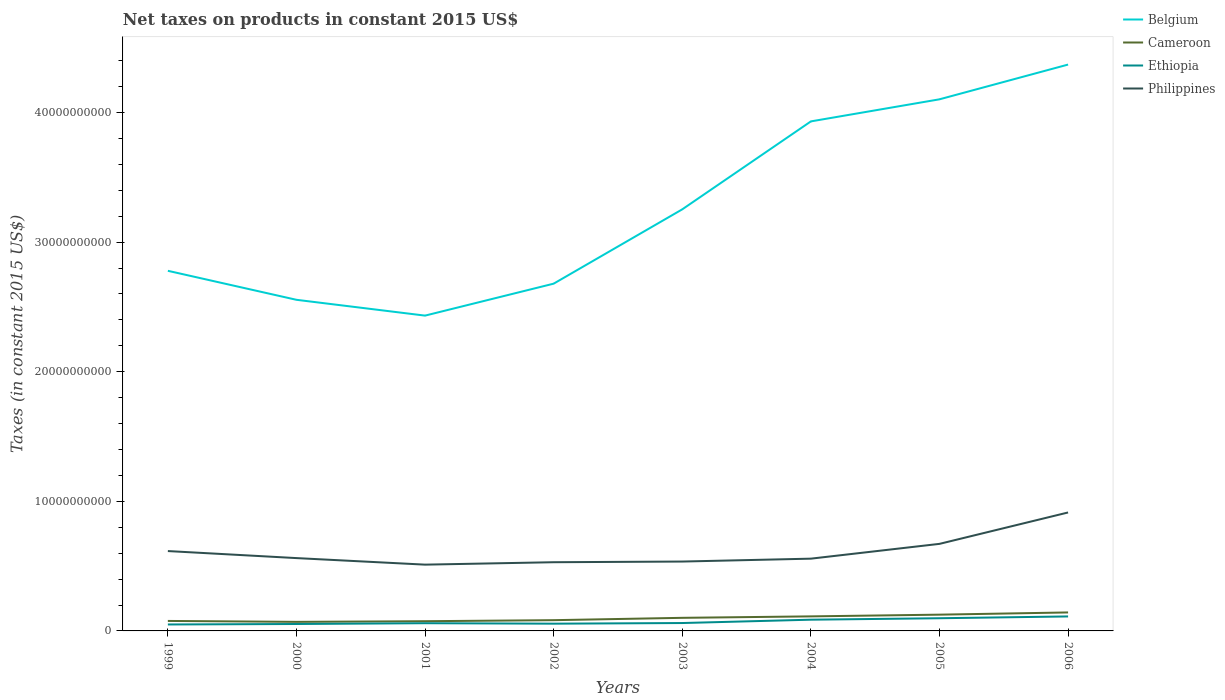Across all years, what is the maximum net taxes on products in Philippines?
Ensure brevity in your answer.  5.11e+09. In which year was the net taxes on products in Philippines maximum?
Your answer should be very brief. 2001. What is the total net taxes on products in Belgium in the graph?
Your answer should be compact. -1.67e+1. What is the difference between the highest and the second highest net taxes on products in Philippines?
Keep it short and to the point. 4.03e+09. What is the difference between the highest and the lowest net taxes on products in Philippines?
Offer a very short reply. 3. What is the difference between two consecutive major ticks on the Y-axis?
Provide a succinct answer. 1.00e+1. Where does the legend appear in the graph?
Give a very brief answer. Top right. How many legend labels are there?
Offer a terse response. 4. What is the title of the graph?
Your answer should be compact. Net taxes on products in constant 2015 US$. What is the label or title of the X-axis?
Offer a very short reply. Years. What is the label or title of the Y-axis?
Your response must be concise. Taxes (in constant 2015 US$). What is the Taxes (in constant 2015 US$) of Belgium in 1999?
Ensure brevity in your answer.  2.78e+1. What is the Taxes (in constant 2015 US$) of Cameroon in 1999?
Offer a very short reply. 7.70e+08. What is the Taxes (in constant 2015 US$) of Ethiopia in 1999?
Provide a succinct answer. 4.98e+08. What is the Taxes (in constant 2015 US$) of Philippines in 1999?
Give a very brief answer. 6.16e+09. What is the Taxes (in constant 2015 US$) of Belgium in 2000?
Your answer should be very brief. 2.56e+1. What is the Taxes (in constant 2015 US$) of Cameroon in 2000?
Offer a very short reply. 6.99e+08. What is the Taxes (in constant 2015 US$) in Ethiopia in 2000?
Keep it short and to the point. 5.34e+08. What is the Taxes (in constant 2015 US$) in Philippines in 2000?
Keep it short and to the point. 5.62e+09. What is the Taxes (in constant 2015 US$) in Belgium in 2001?
Keep it short and to the point. 2.43e+1. What is the Taxes (in constant 2015 US$) in Cameroon in 2001?
Provide a short and direct response. 7.50e+08. What is the Taxes (in constant 2015 US$) in Ethiopia in 2001?
Give a very brief answer. 5.95e+08. What is the Taxes (in constant 2015 US$) in Philippines in 2001?
Your answer should be compact. 5.11e+09. What is the Taxes (in constant 2015 US$) of Belgium in 2002?
Your response must be concise. 2.68e+1. What is the Taxes (in constant 2015 US$) in Cameroon in 2002?
Your answer should be very brief. 8.30e+08. What is the Taxes (in constant 2015 US$) in Ethiopia in 2002?
Offer a terse response. 5.59e+08. What is the Taxes (in constant 2015 US$) of Philippines in 2002?
Provide a succinct answer. 5.30e+09. What is the Taxes (in constant 2015 US$) in Belgium in 2003?
Give a very brief answer. 3.25e+1. What is the Taxes (in constant 2015 US$) in Cameroon in 2003?
Provide a succinct answer. 1.01e+09. What is the Taxes (in constant 2015 US$) of Ethiopia in 2003?
Your answer should be compact. 6.09e+08. What is the Taxes (in constant 2015 US$) of Philippines in 2003?
Your answer should be compact. 5.35e+09. What is the Taxes (in constant 2015 US$) in Belgium in 2004?
Your response must be concise. 3.93e+1. What is the Taxes (in constant 2015 US$) in Cameroon in 2004?
Your response must be concise. 1.12e+09. What is the Taxes (in constant 2015 US$) of Ethiopia in 2004?
Provide a short and direct response. 8.67e+08. What is the Taxes (in constant 2015 US$) of Philippines in 2004?
Give a very brief answer. 5.58e+09. What is the Taxes (in constant 2015 US$) of Belgium in 2005?
Ensure brevity in your answer.  4.10e+1. What is the Taxes (in constant 2015 US$) in Cameroon in 2005?
Your response must be concise. 1.26e+09. What is the Taxes (in constant 2015 US$) in Ethiopia in 2005?
Your answer should be very brief. 9.79e+08. What is the Taxes (in constant 2015 US$) in Philippines in 2005?
Make the answer very short. 6.72e+09. What is the Taxes (in constant 2015 US$) in Belgium in 2006?
Provide a succinct answer. 4.37e+1. What is the Taxes (in constant 2015 US$) in Cameroon in 2006?
Ensure brevity in your answer.  1.43e+09. What is the Taxes (in constant 2015 US$) of Ethiopia in 2006?
Offer a very short reply. 1.12e+09. What is the Taxes (in constant 2015 US$) of Philippines in 2006?
Make the answer very short. 9.14e+09. Across all years, what is the maximum Taxes (in constant 2015 US$) in Belgium?
Your response must be concise. 4.37e+1. Across all years, what is the maximum Taxes (in constant 2015 US$) of Cameroon?
Ensure brevity in your answer.  1.43e+09. Across all years, what is the maximum Taxes (in constant 2015 US$) in Ethiopia?
Provide a succinct answer. 1.12e+09. Across all years, what is the maximum Taxes (in constant 2015 US$) in Philippines?
Ensure brevity in your answer.  9.14e+09. Across all years, what is the minimum Taxes (in constant 2015 US$) of Belgium?
Keep it short and to the point. 2.43e+1. Across all years, what is the minimum Taxes (in constant 2015 US$) in Cameroon?
Provide a short and direct response. 6.99e+08. Across all years, what is the minimum Taxes (in constant 2015 US$) of Ethiopia?
Ensure brevity in your answer.  4.98e+08. Across all years, what is the minimum Taxes (in constant 2015 US$) in Philippines?
Provide a succinct answer. 5.11e+09. What is the total Taxes (in constant 2015 US$) in Belgium in the graph?
Make the answer very short. 2.61e+11. What is the total Taxes (in constant 2015 US$) in Cameroon in the graph?
Keep it short and to the point. 7.86e+09. What is the total Taxes (in constant 2015 US$) of Ethiopia in the graph?
Provide a short and direct response. 5.76e+09. What is the total Taxes (in constant 2015 US$) in Philippines in the graph?
Provide a short and direct response. 4.90e+1. What is the difference between the Taxes (in constant 2015 US$) in Belgium in 1999 and that in 2000?
Provide a short and direct response. 2.24e+09. What is the difference between the Taxes (in constant 2015 US$) in Cameroon in 1999 and that in 2000?
Keep it short and to the point. 7.11e+07. What is the difference between the Taxes (in constant 2015 US$) of Ethiopia in 1999 and that in 2000?
Provide a short and direct response. -3.62e+07. What is the difference between the Taxes (in constant 2015 US$) in Philippines in 1999 and that in 2000?
Make the answer very short. 5.43e+08. What is the difference between the Taxes (in constant 2015 US$) of Belgium in 1999 and that in 2001?
Provide a short and direct response. 3.46e+09. What is the difference between the Taxes (in constant 2015 US$) of Cameroon in 1999 and that in 2001?
Offer a very short reply. 2.08e+07. What is the difference between the Taxes (in constant 2015 US$) in Ethiopia in 1999 and that in 2001?
Your answer should be very brief. -9.77e+07. What is the difference between the Taxes (in constant 2015 US$) of Philippines in 1999 and that in 2001?
Offer a terse response. 1.05e+09. What is the difference between the Taxes (in constant 2015 US$) in Belgium in 1999 and that in 2002?
Give a very brief answer. 9.92e+08. What is the difference between the Taxes (in constant 2015 US$) in Cameroon in 1999 and that in 2002?
Make the answer very short. -5.92e+07. What is the difference between the Taxes (in constant 2015 US$) of Ethiopia in 1999 and that in 2002?
Make the answer very short. -6.17e+07. What is the difference between the Taxes (in constant 2015 US$) in Philippines in 1999 and that in 2002?
Your answer should be very brief. 8.62e+08. What is the difference between the Taxes (in constant 2015 US$) in Belgium in 1999 and that in 2003?
Your answer should be compact. -4.74e+09. What is the difference between the Taxes (in constant 2015 US$) in Cameroon in 1999 and that in 2003?
Offer a very short reply. -2.40e+08. What is the difference between the Taxes (in constant 2015 US$) in Ethiopia in 1999 and that in 2003?
Offer a terse response. -1.12e+08. What is the difference between the Taxes (in constant 2015 US$) of Philippines in 1999 and that in 2003?
Make the answer very short. 8.09e+08. What is the difference between the Taxes (in constant 2015 US$) of Belgium in 1999 and that in 2004?
Offer a terse response. -1.15e+1. What is the difference between the Taxes (in constant 2015 US$) of Cameroon in 1999 and that in 2004?
Make the answer very short. -3.52e+08. What is the difference between the Taxes (in constant 2015 US$) in Ethiopia in 1999 and that in 2004?
Your answer should be compact. -3.70e+08. What is the difference between the Taxes (in constant 2015 US$) in Philippines in 1999 and that in 2004?
Make the answer very short. 5.86e+08. What is the difference between the Taxes (in constant 2015 US$) in Belgium in 1999 and that in 2005?
Ensure brevity in your answer.  -1.32e+1. What is the difference between the Taxes (in constant 2015 US$) of Cameroon in 1999 and that in 2005?
Ensure brevity in your answer.  -4.85e+08. What is the difference between the Taxes (in constant 2015 US$) of Ethiopia in 1999 and that in 2005?
Your answer should be compact. -4.81e+08. What is the difference between the Taxes (in constant 2015 US$) of Philippines in 1999 and that in 2005?
Ensure brevity in your answer.  -5.55e+08. What is the difference between the Taxes (in constant 2015 US$) in Belgium in 1999 and that in 2006?
Your response must be concise. -1.59e+1. What is the difference between the Taxes (in constant 2015 US$) in Cameroon in 1999 and that in 2006?
Your answer should be compact. -6.56e+08. What is the difference between the Taxes (in constant 2015 US$) of Ethiopia in 1999 and that in 2006?
Provide a succinct answer. -6.20e+08. What is the difference between the Taxes (in constant 2015 US$) in Philippines in 1999 and that in 2006?
Your answer should be compact. -2.98e+09. What is the difference between the Taxes (in constant 2015 US$) of Belgium in 2000 and that in 2001?
Provide a short and direct response. 1.22e+09. What is the difference between the Taxes (in constant 2015 US$) of Cameroon in 2000 and that in 2001?
Make the answer very short. -5.02e+07. What is the difference between the Taxes (in constant 2015 US$) in Ethiopia in 2000 and that in 2001?
Make the answer very short. -6.16e+07. What is the difference between the Taxes (in constant 2015 US$) in Philippines in 2000 and that in 2001?
Provide a succinct answer. 5.04e+08. What is the difference between the Taxes (in constant 2015 US$) of Belgium in 2000 and that in 2002?
Make the answer very short. -1.25e+09. What is the difference between the Taxes (in constant 2015 US$) in Cameroon in 2000 and that in 2002?
Your answer should be very brief. -1.30e+08. What is the difference between the Taxes (in constant 2015 US$) in Ethiopia in 2000 and that in 2002?
Offer a terse response. -2.56e+07. What is the difference between the Taxes (in constant 2015 US$) of Philippines in 2000 and that in 2002?
Your response must be concise. 3.18e+08. What is the difference between the Taxes (in constant 2015 US$) in Belgium in 2000 and that in 2003?
Your response must be concise. -6.98e+09. What is the difference between the Taxes (in constant 2015 US$) of Cameroon in 2000 and that in 2003?
Offer a terse response. -3.11e+08. What is the difference between the Taxes (in constant 2015 US$) of Ethiopia in 2000 and that in 2003?
Offer a very short reply. -7.56e+07. What is the difference between the Taxes (in constant 2015 US$) in Philippines in 2000 and that in 2003?
Your answer should be very brief. 2.66e+08. What is the difference between the Taxes (in constant 2015 US$) in Belgium in 2000 and that in 2004?
Your answer should be very brief. -1.38e+1. What is the difference between the Taxes (in constant 2015 US$) of Cameroon in 2000 and that in 2004?
Your answer should be compact. -4.23e+08. What is the difference between the Taxes (in constant 2015 US$) in Ethiopia in 2000 and that in 2004?
Give a very brief answer. -3.34e+08. What is the difference between the Taxes (in constant 2015 US$) of Philippines in 2000 and that in 2004?
Give a very brief answer. 4.29e+07. What is the difference between the Taxes (in constant 2015 US$) in Belgium in 2000 and that in 2005?
Provide a succinct answer. -1.55e+1. What is the difference between the Taxes (in constant 2015 US$) of Cameroon in 2000 and that in 2005?
Keep it short and to the point. -5.56e+08. What is the difference between the Taxes (in constant 2015 US$) of Ethiopia in 2000 and that in 2005?
Your answer should be compact. -4.45e+08. What is the difference between the Taxes (in constant 2015 US$) in Philippines in 2000 and that in 2005?
Keep it short and to the point. -1.10e+09. What is the difference between the Taxes (in constant 2015 US$) of Belgium in 2000 and that in 2006?
Offer a terse response. -1.82e+1. What is the difference between the Taxes (in constant 2015 US$) in Cameroon in 2000 and that in 2006?
Your answer should be very brief. -7.27e+08. What is the difference between the Taxes (in constant 2015 US$) of Ethiopia in 2000 and that in 2006?
Give a very brief answer. -5.83e+08. What is the difference between the Taxes (in constant 2015 US$) in Philippines in 2000 and that in 2006?
Provide a succinct answer. -3.52e+09. What is the difference between the Taxes (in constant 2015 US$) in Belgium in 2001 and that in 2002?
Give a very brief answer. -2.47e+09. What is the difference between the Taxes (in constant 2015 US$) in Cameroon in 2001 and that in 2002?
Ensure brevity in your answer.  -8.00e+07. What is the difference between the Taxes (in constant 2015 US$) of Ethiopia in 2001 and that in 2002?
Provide a succinct answer. 3.60e+07. What is the difference between the Taxes (in constant 2015 US$) in Philippines in 2001 and that in 2002?
Provide a short and direct response. -1.86e+08. What is the difference between the Taxes (in constant 2015 US$) in Belgium in 2001 and that in 2003?
Keep it short and to the point. -8.20e+09. What is the difference between the Taxes (in constant 2015 US$) of Cameroon in 2001 and that in 2003?
Provide a short and direct response. -2.61e+08. What is the difference between the Taxes (in constant 2015 US$) of Ethiopia in 2001 and that in 2003?
Your response must be concise. -1.40e+07. What is the difference between the Taxes (in constant 2015 US$) in Philippines in 2001 and that in 2003?
Your answer should be very brief. -2.39e+08. What is the difference between the Taxes (in constant 2015 US$) in Belgium in 2001 and that in 2004?
Your answer should be very brief. -1.50e+1. What is the difference between the Taxes (in constant 2015 US$) in Cameroon in 2001 and that in 2004?
Offer a terse response. -3.72e+08. What is the difference between the Taxes (in constant 2015 US$) of Ethiopia in 2001 and that in 2004?
Your answer should be compact. -2.72e+08. What is the difference between the Taxes (in constant 2015 US$) in Philippines in 2001 and that in 2004?
Your answer should be very brief. -4.62e+08. What is the difference between the Taxes (in constant 2015 US$) in Belgium in 2001 and that in 2005?
Offer a very short reply. -1.67e+1. What is the difference between the Taxes (in constant 2015 US$) of Cameroon in 2001 and that in 2005?
Keep it short and to the point. -5.06e+08. What is the difference between the Taxes (in constant 2015 US$) of Ethiopia in 2001 and that in 2005?
Provide a short and direct response. -3.83e+08. What is the difference between the Taxes (in constant 2015 US$) in Philippines in 2001 and that in 2005?
Your answer should be compact. -1.60e+09. What is the difference between the Taxes (in constant 2015 US$) in Belgium in 2001 and that in 2006?
Provide a succinct answer. -1.94e+1. What is the difference between the Taxes (in constant 2015 US$) in Cameroon in 2001 and that in 2006?
Make the answer very short. -6.77e+08. What is the difference between the Taxes (in constant 2015 US$) of Ethiopia in 2001 and that in 2006?
Provide a short and direct response. -5.22e+08. What is the difference between the Taxes (in constant 2015 US$) of Philippines in 2001 and that in 2006?
Offer a terse response. -4.03e+09. What is the difference between the Taxes (in constant 2015 US$) in Belgium in 2002 and that in 2003?
Offer a terse response. -5.74e+09. What is the difference between the Taxes (in constant 2015 US$) of Cameroon in 2002 and that in 2003?
Your answer should be compact. -1.81e+08. What is the difference between the Taxes (in constant 2015 US$) in Ethiopia in 2002 and that in 2003?
Your answer should be compact. -5.00e+07. What is the difference between the Taxes (in constant 2015 US$) of Philippines in 2002 and that in 2003?
Your answer should be very brief. -5.27e+07. What is the difference between the Taxes (in constant 2015 US$) of Belgium in 2002 and that in 2004?
Ensure brevity in your answer.  -1.25e+1. What is the difference between the Taxes (in constant 2015 US$) of Cameroon in 2002 and that in 2004?
Offer a terse response. -2.93e+08. What is the difference between the Taxes (in constant 2015 US$) in Ethiopia in 2002 and that in 2004?
Offer a very short reply. -3.08e+08. What is the difference between the Taxes (in constant 2015 US$) of Philippines in 2002 and that in 2004?
Ensure brevity in your answer.  -2.76e+08. What is the difference between the Taxes (in constant 2015 US$) of Belgium in 2002 and that in 2005?
Offer a terse response. -1.42e+1. What is the difference between the Taxes (in constant 2015 US$) in Cameroon in 2002 and that in 2005?
Offer a terse response. -4.26e+08. What is the difference between the Taxes (in constant 2015 US$) of Ethiopia in 2002 and that in 2005?
Your response must be concise. -4.19e+08. What is the difference between the Taxes (in constant 2015 US$) of Philippines in 2002 and that in 2005?
Make the answer very short. -1.42e+09. What is the difference between the Taxes (in constant 2015 US$) in Belgium in 2002 and that in 2006?
Ensure brevity in your answer.  -1.69e+1. What is the difference between the Taxes (in constant 2015 US$) in Cameroon in 2002 and that in 2006?
Your answer should be very brief. -5.97e+08. What is the difference between the Taxes (in constant 2015 US$) of Ethiopia in 2002 and that in 2006?
Keep it short and to the point. -5.58e+08. What is the difference between the Taxes (in constant 2015 US$) of Philippines in 2002 and that in 2006?
Keep it short and to the point. -3.84e+09. What is the difference between the Taxes (in constant 2015 US$) in Belgium in 2003 and that in 2004?
Your answer should be very brief. -6.79e+09. What is the difference between the Taxes (in constant 2015 US$) in Cameroon in 2003 and that in 2004?
Ensure brevity in your answer.  -1.11e+08. What is the difference between the Taxes (in constant 2015 US$) of Ethiopia in 2003 and that in 2004?
Keep it short and to the point. -2.58e+08. What is the difference between the Taxes (in constant 2015 US$) of Philippines in 2003 and that in 2004?
Provide a succinct answer. -2.23e+08. What is the difference between the Taxes (in constant 2015 US$) in Belgium in 2003 and that in 2005?
Offer a terse response. -8.49e+09. What is the difference between the Taxes (in constant 2015 US$) of Cameroon in 2003 and that in 2005?
Keep it short and to the point. -2.44e+08. What is the difference between the Taxes (in constant 2015 US$) of Ethiopia in 2003 and that in 2005?
Give a very brief answer. -3.69e+08. What is the difference between the Taxes (in constant 2015 US$) of Philippines in 2003 and that in 2005?
Your response must be concise. -1.36e+09. What is the difference between the Taxes (in constant 2015 US$) in Belgium in 2003 and that in 2006?
Provide a short and direct response. -1.12e+1. What is the difference between the Taxes (in constant 2015 US$) in Cameroon in 2003 and that in 2006?
Your answer should be very brief. -4.15e+08. What is the difference between the Taxes (in constant 2015 US$) of Ethiopia in 2003 and that in 2006?
Keep it short and to the point. -5.08e+08. What is the difference between the Taxes (in constant 2015 US$) of Philippines in 2003 and that in 2006?
Offer a terse response. -3.79e+09. What is the difference between the Taxes (in constant 2015 US$) in Belgium in 2004 and that in 2005?
Provide a short and direct response. -1.70e+09. What is the difference between the Taxes (in constant 2015 US$) of Cameroon in 2004 and that in 2005?
Make the answer very short. -1.33e+08. What is the difference between the Taxes (in constant 2015 US$) in Ethiopia in 2004 and that in 2005?
Offer a very short reply. -1.11e+08. What is the difference between the Taxes (in constant 2015 US$) of Philippines in 2004 and that in 2005?
Your answer should be very brief. -1.14e+09. What is the difference between the Taxes (in constant 2015 US$) in Belgium in 2004 and that in 2006?
Your answer should be compact. -4.39e+09. What is the difference between the Taxes (in constant 2015 US$) of Cameroon in 2004 and that in 2006?
Ensure brevity in your answer.  -3.04e+08. What is the difference between the Taxes (in constant 2015 US$) in Ethiopia in 2004 and that in 2006?
Provide a short and direct response. -2.50e+08. What is the difference between the Taxes (in constant 2015 US$) in Philippines in 2004 and that in 2006?
Keep it short and to the point. -3.56e+09. What is the difference between the Taxes (in constant 2015 US$) in Belgium in 2005 and that in 2006?
Your answer should be compact. -2.68e+09. What is the difference between the Taxes (in constant 2015 US$) in Cameroon in 2005 and that in 2006?
Keep it short and to the point. -1.71e+08. What is the difference between the Taxes (in constant 2015 US$) of Ethiopia in 2005 and that in 2006?
Offer a terse response. -1.39e+08. What is the difference between the Taxes (in constant 2015 US$) of Philippines in 2005 and that in 2006?
Your answer should be very brief. -2.42e+09. What is the difference between the Taxes (in constant 2015 US$) of Belgium in 1999 and the Taxes (in constant 2015 US$) of Cameroon in 2000?
Keep it short and to the point. 2.71e+1. What is the difference between the Taxes (in constant 2015 US$) of Belgium in 1999 and the Taxes (in constant 2015 US$) of Ethiopia in 2000?
Give a very brief answer. 2.73e+1. What is the difference between the Taxes (in constant 2015 US$) in Belgium in 1999 and the Taxes (in constant 2015 US$) in Philippines in 2000?
Your response must be concise. 2.22e+1. What is the difference between the Taxes (in constant 2015 US$) of Cameroon in 1999 and the Taxes (in constant 2015 US$) of Ethiopia in 2000?
Provide a short and direct response. 2.37e+08. What is the difference between the Taxes (in constant 2015 US$) in Cameroon in 1999 and the Taxes (in constant 2015 US$) in Philippines in 2000?
Make the answer very short. -4.85e+09. What is the difference between the Taxes (in constant 2015 US$) of Ethiopia in 1999 and the Taxes (in constant 2015 US$) of Philippines in 2000?
Ensure brevity in your answer.  -5.12e+09. What is the difference between the Taxes (in constant 2015 US$) of Belgium in 1999 and the Taxes (in constant 2015 US$) of Cameroon in 2001?
Offer a terse response. 2.70e+1. What is the difference between the Taxes (in constant 2015 US$) in Belgium in 1999 and the Taxes (in constant 2015 US$) in Ethiopia in 2001?
Your answer should be compact. 2.72e+1. What is the difference between the Taxes (in constant 2015 US$) in Belgium in 1999 and the Taxes (in constant 2015 US$) in Philippines in 2001?
Provide a short and direct response. 2.27e+1. What is the difference between the Taxes (in constant 2015 US$) of Cameroon in 1999 and the Taxes (in constant 2015 US$) of Ethiopia in 2001?
Offer a very short reply. 1.75e+08. What is the difference between the Taxes (in constant 2015 US$) in Cameroon in 1999 and the Taxes (in constant 2015 US$) in Philippines in 2001?
Provide a short and direct response. -4.34e+09. What is the difference between the Taxes (in constant 2015 US$) of Ethiopia in 1999 and the Taxes (in constant 2015 US$) of Philippines in 2001?
Ensure brevity in your answer.  -4.62e+09. What is the difference between the Taxes (in constant 2015 US$) in Belgium in 1999 and the Taxes (in constant 2015 US$) in Cameroon in 2002?
Keep it short and to the point. 2.70e+1. What is the difference between the Taxes (in constant 2015 US$) of Belgium in 1999 and the Taxes (in constant 2015 US$) of Ethiopia in 2002?
Ensure brevity in your answer.  2.72e+1. What is the difference between the Taxes (in constant 2015 US$) in Belgium in 1999 and the Taxes (in constant 2015 US$) in Philippines in 2002?
Keep it short and to the point. 2.25e+1. What is the difference between the Taxes (in constant 2015 US$) in Cameroon in 1999 and the Taxes (in constant 2015 US$) in Ethiopia in 2002?
Your answer should be compact. 2.11e+08. What is the difference between the Taxes (in constant 2015 US$) in Cameroon in 1999 and the Taxes (in constant 2015 US$) in Philippines in 2002?
Your answer should be very brief. -4.53e+09. What is the difference between the Taxes (in constant 2015 US$) of Ethiopia in 1999 and the Taxes (in constant 2015 US$) of Philippines in 2002?
Your response must be concise. -4.80e+09. What is the difference between the Taxes (in constant 2015 US$) of Belgium in 1999 and the Taxes (in constant 2015 US$) of Cameroon in 2003?
Your answer should be very brief. 2.68e+1. What is the difference between the Taxes (in constant 2015 US$) of Belgium in 1999 and the Taxes (in constant 2015 US$) of Ethiopia in 2003?
Provide a succinct answer. 2.72e+1. What is the difference between the Taxes (in constant 2015 US$) in Belgium in 1999 and the Taxes (in constant 2015 US$) in Philippines in 2003?
Make the answer very short. 2.24e+1. What is the difference between the Taxes (in constant 2015 US$) in Cameroon in 1999 and the Taxes (in constant 2015 US$) in Ethiopia in 2003?
Give a very brief answer. 1.61e+08. What is the difference between the Taxes (in constant 2015 US$) of Cameroon in 1999 and the Taxes (in constant 2015 US$) of Philippines in 2003?
Make the answer very short. -4.58e+09. What is the difference between the Taxes (in constant 2015 US$) in Ethiopia in 1999 and the Taxes (in constant 2015 US$) in Philippines in 2003?
Offer a very short reply. -4.86e+09. What is the difference between the Taxes (in constant 2015 US$) of Belgium in 1999 and the Taxes (in constant 2015 US$) of Cameroon in 2004?
Ensure brevity in your answer.  2.67e+1. What is the difference between the Taxes (in constant 2015 US$) in Belgium in 1999 and the Taxes (in constant 2015 US$) in Ethiopia in 2004?
Ensure brevity in your answer.  2.69e+1. What is the difference between the Taxes (in constant 2015 US$) of Belgium in 1999 and the Taxes (in constant 2015 US$) of Philippines in 2004?
Offer a terse response. 2.22e+1. What is the difference between the Taxes (in constant 2015 US$) in Cameroon in 1999 and the Taxes (in constant 2015 US$) in Ethiopia in 2004?
Offer a very short reply. -9.69e+07. What is the difference between the Taxes (in constant 2015 US$) in Cameroon in 1999 and the Taxes (in constant 2015 US$) in Philippines in 2004?
Make the answer very short. -4.81e+09. What is the difference between the Taxes (in constant 2015 US$) of Ethiopia in 1999 and the Taxes (in constant 2015 US$) of Philippines in 2004?
Provide a short and direct response. -5.08e+09. What is the difference between the Taxes (in constant 2015 US$) of Belgium in 1999 and the Taxes (in constant 2015 US$) of Cameroon in 2005?
Provide a short and direct response. 2.65e+1. What is the difference between the Taxes (in constant 2015 US$) of Belgium in 1999 and the Taxes (in constant 2015 US$) of Ethiopia in 2005?
Offer a very short reply. 2.68e+1. What is the difference between the Taxes (in constant 2015 US$) of Belgium in 1999 and the Taxes (in constant 2015 US$) of Philippines in 2005?
Provide a succinct answer. 2.11e+1. What is the difference between the Taxes (in constant 2015 US$) of Cameroon in 1999 and the Taxes (in constant 2015 US$) of Ethiopia in 2005?
Give a very brief answer. -2.08e+08. What is the difference between the Taxes (in constant 2015 US$) of Cameroon in 1999 and the Taxes (in constant 2015 US$) of Philippines in 2005?
Offer a very short reply. -5.95e+09. What is the difference between the Taxes (in constant 2015 US$) of Ethiopia in 1999 and the Taxes (in constant 2015 US$) of Philippines in 2005?
Make the answer very short. -6.22e+09. What is the difference between the Taxes (in constant 2015 US$) of Belgium in 1999 and the Taxes (in constant 2015 US$) of Cameroon in 2006?
Offer a terse response. 2.64e+1. What is the difference between the Taxes (in constant 2015 US$) of Belgium in 1999 and the Taxes (in constant 2015 US$) of Ethiopia in 2006?
Give a very brief answer. 2.67e+1. What is the difference between the Taxes (in constant 2015 US$) in Belgium in 1999 and the Taxes (in constant 2015 US$) in Philippines in 2006?
Your response must be concise. 1.86e+1. What is the difference between the Taxes (in constant 2015 US$) in Cameroon in 1999 and the Taxes (in constant 2015 US$) in Ethiopia in 2006?
Provide a succinct answer. -3.47e+08. What is the difference between the Taxes (in constant 2015 US$) of Cameroon in 1999 and the Taxes (in constant 2015 US$) of Philippines in 2006?
Provide a short and direct response. -8.37e+09. What is the difference between the Taxes (in constant 2015 US$) in Ethiopia in 1999 and the Taxes (in constant 2015 US$) in Philippines in 2006?
Provide a short and direct response. -8.64e+09. What is the difference between the Taxes (in constant 2015 US$) of Belgium in 2000 and the Taxes (in constant 2015 US$) of Cameroon in 2001?
Your response must be concise. 2.48e+1. What is the difference between the Taxes (in constant 2015 US$) in Belgium in 2000 and the Taxes (in constant 2015 US$) in Ethiopia in 2001?
Provide a succinct answer. 2.50e+1. What is the difference between the Taxes (in constant 2015 US$) of Belgium in 2000 and the Taxes (in constant 2015 US$) of Philippines in 2001?
Ensure brevity in your answer.  2.04e+1. What is the difference between the Taxes (in constant 2015 US$) of Cameroon in 2000 and the Taxes (in constant 2015 US$) of Ethiopia in 2001?
Offer a terse response. 1.04e+08. What is the difference between the Taxes (in constant 2015 US$) in Cameroon in 2000 and the Taxes (in constant 2015 US$) in Philippines in 2001?
Your response must be concise. -4.42e+09. What is the difference between the Taxes (in constant 2015 US$) of Ethiopia in 2000 and the Taxes (in constant 2015 US$) of Philippines in 2001?
Your response must be concise. -4.58e+09. What is the difference between the Taxes (in constant 2015 US$) of Belgium in 2000 and the Taxes (in constant 2015 US$) of Cameroon in 2002?
Ensure brevity in your answer.  2.47e+1. What is the difference between the Taxes (in constant 2015 US$) in Belgium in 2000 and the Taxes (in constant 2015 US$) in Ethiopia in 2002?
Make the answer very short. 2.50e+1. What is the difference between the Taxes (in constant 2015 US$) of Belgium in 2000 and the Taxes (in constant 2015 US$) of Philippines in 2002?
Give a very brief answer. 2.02e+1. What is the difference between the Taxes (in constant 2015 US$) of Cameroon in 2000 and the Taxes (in constant 2015 US$) of Ethiopia in 2002?
Give a very brief answer. 1.40e+08. What is the difference between the Taxes (in constant 2015 US$) in Cameroon in 2000 and the Taxes (in constant 2015 US$) in Philippines in 2002?
Offer a terse response. -4.60e+09. What is the difference between the Taxes (in constant 2015 US$) of Ethiopia in 2000 and the Taxes (in constant 2015 US$) of Philippines in 2002?
Offer a terse response. -4.77e+09. What is the difference between the Taxes (in constant 2015 US$) in Belgium in 2000 and the Taxes (in constant 2015 US$) in Cameroon in 2003?
Offer a very short reply. 2.45e+1. What is the difference between the Taxes (in constant 2015 US$) of Belgium in 2000 and the Taxes (in constant 2015 US$) of Ethiopia in 2003?
Provide a short and direct response. 2.49e+1. What is the difference between the Taxes (in constant 2015 US$) in Belgium in 2000 and the Taxes (in constant 2015 US$) in Philippines in 2003?
Offer a very short reply. 2.02e+1. What is the difference between the Taxes (in constant 2015 US$) of Cameroon in 2000 and the Taxes (in constant 2015 US$) of Ethiopia in 2003?
Ensure brevity in your answer.  9.00e+07. What is the difference between the Taxes (in constant 2015 US$) in Cameroon in 2000 and the Taxes (in constant 2015 US$) in Philippines in 2003?
Your answer should be compact. -4.65e+09. What is the difference between the Taxes (in constant 2015 US$) in Ethiopia in 2000 and the Taxes (in constant 2015 US$) in Philippines in 2003?
Ensure brevity in your answer.  -4.82e+09. What is the difference between the Taxes (in constant 2015 US$) of Belgium in 2000 and the Taxes (in constant 2015 US$) of Cameroon in 2004?
Provide a succinct answer. 2.44e+1. What is the difference between the Taxes (in constant 2015 US$) of Belgium in 2000 and the Taxes (in constant 2015 US$) of Ethiopia in 2004?
Make the answer very short. 2.47e+1. What is the difference between the Taxes (in constant 2015 US$) of Belgium in 2000 and the Taxes (in constant 2015 US$) of Philippines in 2004?
Make the answer very short. 2.00e+1. What is the difference between the Taxes (in constant 2015 US$) in Cameroon in 2000 and the Taxes (in constant 2015 US$) in Ethiopia in 2004?
Provide a short and direct response. -1.68e+08. What is the difference between the Taxes (in constant 2015 US$) in Cameroon in 2000 and the Taxes (in constant 2015 US$) in Philippines in 2004?
Your response must be concise. -4.88e+09. What is the difference between the Taxes (in constant 2015 US$) in Ethiopia in 2000 and the Taxes (in constant 2015 US$) in Philippines in 2004?
Offer a terse response. -5.04e+09. What is the difference between the Taxes (in constant 2015 US$) in Belgium in 2000 and the Taxes (in constant 2015 US$) in Cameroon in 2005?
Make the answer very short. 2.43e+1. What is the difference between the Taxes (in constant 2015 US$) of Belgium in 2000 and the Taxes (in constant 2015 US$) of Ethiopia in 2005?
Keep it short and to the point. 2.46e+1. What is the difference between the Taxes (in constant 2015 US$) of Belgium in 2000 and the Taxes (in constant 2015 US$) of Philippines in 2005?
Ensure brevity in your answer.  1.88e+1. What is the difference between the Taxes (in constant 2015 US$) in Cameroon in 2000 and the Taxes (in constant 2015 US$) in Ethiopia in 2005?
Ensure brevity in your answer.  -2.79e+08. What is the difference between the Taxes (in constant 2015 US$) of Cameroon in 2000 and the Taxes (in constant 2015 US$) of Philippines in 2005?
Your answer should be very brief. -6.02e+09. What is the difference between the Taxes (in constant 2015 US$) of Ethiopia in 2000 and the Taxes (in constant 2015 US$) of Philippines in 2005?
Your answer should be compact. -6.18e+09. What is the difference between the Taxes (in constant 2015 US$) of Belgium in 2000 and the Taxes (in constant 2015 US$) of Cameroon in 2006?
Make the answer very short. 2.41e+1. What is the difference between the Taxes (in constant 2015 US$) of Belgium in 2000 and the Taxes (in constant 2015 US$) of Ethiopia in 2006?
Ensure brevity in your answer.  2.44e+1. What is the difference between the Taxes (in constant 2015 US$) of Belgium in 2000 and the Taxes (in constant 2015 US$) of Philippines in 2006?
Your answer should be very brief. 1.64e+1. What is the difference between the Taxes (in constant 2015 US$) of Cameroon in 2000 and the Taxes (in constant 2015 US$) of Ethiopia in 2006?
Your answer should be compact. -4.18e+08. What is the difference between the Taxes (in constant 2015 US$) of Cameroon in 2000 and the Taxes (in constant 2015 US$) of Philippines in 2006?
Keep it short and to the point. -8.44e+09. What is the difference between the Taxes (in constant 2015 US$) in Ethiopia in 2000 and the Taxes (in constant 2015 US$) in Philippines in 2006?
Keep it short and to the point. -8.61e+09. What is the difference between the Taxes (in constant 2015 US$) in Belgium in 2001 and the Taxes (in constant 2015 US$) in Cameroon in 2002?
Offer a very short reply. 2.35e+1. What is the difference between the Taxes (in constant 2015 US$) of Belgium in 2001 and the Taxes (in constant 2015 US$) of Ethiopia in 2002?
Offer a very short reply. 2.38e+1. What is the difference between the Taxes (in constant 2015 US$) in Belgium in 2001 and the Taxes (in constant 2015 US$) in Philippines in 2002?
Provide a succinct answer. 1.90e+1. What is the difference between the Taxes (in constant 2015 US$) of Cameroon in 2001 and the Taxes (in constant 2015 US$) of Ethiopia in 2002?
Keep it short and to the point. 1.90e+08. What is the difference between the Taxes (in constant 2015 US$) of Cameroon in 2001 and the Taxes (in constant 2015 US$) of Philippines in 2002?
Give a very brief answer. -4.55e+09. What is the difference between the Taxes (in constant 2015 US$) of Ethiopia in 2001 and the Taxes (in constant 2015 US$) of Philippines in 2002?
Keep it short and to the point. -4.71e+09. What is the difference between the Taxes (in constant 2015 US$) of Belgium in 2001 and the Taxes (in constant 2015 US$) of Cameroon in 2003?
Provide a short and direct response. 2.33e+1. What is the difference between the Taxes (in constant 2015 US$) in Belgium in 2001 and the Taxes (in constant 2015 US$) in Ethiopia in 2003?
Provide a short and direct response. 2.37e+1. What is the difference between the Taxes (in constant 2015 US$) of Belgium in 2001 and the Taxes (in constant 2015 US$) of Philippines in 2003?
Ensure brevity in your answer.  1.90e+1. What is the difference between the Taxes (in constant 2015 US$) in Cameroon in 2001 and the Taxes (in constant 2015 US$) in Ethiopia in 2003?
Offer a terse response. 1.40e+08. What is the difference between the Taxes (in constant 2015 US$) in Cameroon in 2001 and the Taxes (in constant 2015 US$) in Philippines in 2003?
Your answer should be very brief. -4.60e+09. What is the difference between the Taxes (in constant 2015 US$) of Ethiopia in 2001 and the Taxes (in constant 2015 US$) of Philippines in 2003?
Your response must be concise. -4.76e+09. What is the difference between the Taxes (in constant 2015 US$) in Belgium in 2001 and the Taxes (in constant 2015 US$) in Cameroon in 2004?
Keep it short and to the point. 2.32e+1. What is the difference between the Taxes (in constant 2015 US$) in Belgium in 2001 and the Taxes (in constant 2015 US$) in Ethiopia in 2004?
Give a very brief answer. 2.35e+1. What is the difference between the Taxes (in constant 2015 US$) of Belgium in 2001 and the Taxes (in constant 2015 US$) of Philippines in 2004?
Give a very brief answer. 1.88e+1. What is the difference between the Taxes (in constant 2015 US$) of Cameroon in 2001 and the Taxes (in constant 2015 US$) of Ethiopia in 2004?
Give a very brief answer. -1.18e+08. What is the difference between the Taxes (in constant 2015 US$) of Cameroon in 2001 and the Taxes (in constant 2015 US$) of Philippines in 2004?
Give a very brief answer. -4.83e+09. What is the difference between the Taxes (in constant 2015 US$) in Ethiopia in 2001 and the Taxes (in constant 2015 US$) in Philippines in 2004?
Your response must be concise. -4.98e+09. What is the difference between the Taxes (in constant 2015 US$) in Belgium in 2001 and the Taxes (in constant 2015 US$) in Cameroon in 2005?
Keep it short and to the point. 2.31e+1. What is the difference between the Taxes (in constant 2015 US$) of Belgium in 2001 and the Taxes (in constant 2015 US$) of Ethiopia in 2005?
Provide a succinct answer. 2.34e+1. What is the difference between the Taxes (in constant 2015 US$) in Belgium in 2001 and the Taxes (in constant 2015 US$) in Philippines in 2005?
Provide a succinct answer. 1.76e+1. What is the difference between the Taxes (in constant 2015 US$) of Cameroon in 2001 and the Taxes (in constant 2015 US$) of Ethiopia in 2005?
Offer a terse response. -2.29e+08. What is the difference between the Taxes (in constant 2015 US$) of Cameroon in 2001 and the Taxes (in constant 2015 US$) of Philippines in 2005?
Keep it short and to the point. -5.97e+09. What is the difference between the Taxes (in constant 2015 US$) of Ethiopia in 2001 and the Taxes (in constant 2015 US$) of Philippines in 2005?
Make the answer very short. -6.12e+09. What is the difference between the Taxes (in constant 2015 US$) in Belgium in 2001 and the Taxes (in constant 2015 US$) in Cameroon in 2006?
Your answer should be compact. 2.29e+1. What is the difference between the Taxes (in constant 2015 US$) of Belgium in 2001 and the Taxes (in constant 2015 US$) of Ethiopia in 2006?
Your answer should be compact. 2.32e+1. What is the difference between the Taxes (in constant 2015 US$) of Belgium in 2001 and the Taxes (in constant 2015 US$) of Philippines in 2006?
Ensure brevity in your answer.  1.52e+1. What is the difference between the Taxes (in constant 2015 US$) in Cameroon in 2001 and the Taxes (in constant 2015 US$) in Ethiopia in 2006?
Offer a very short reply. -3.68e+08. What is the difference between the Taxes (in constant 2015 US$) in Cameroon in 2001 and the Taxes (in constant 2015 US$) in Philippines in 2006?
Your answer should be very brief. -8.39e+09. What is the difference between the Taxes (in constant 2015 US$) of Ethiopia in 2001 and the Taxes (in constant 2015 US$) of Philippines in 2006?
Ensure brevity in your answer.  -8.55e+09. What is the difference between the Taxes (in constant 2015 US$) in Belgium in 2002 and the Taxes (in constant 2015 US$) in Cameroon in 2003?
Your response must be concise. 2.58e+1. What is the difference between the Taxes (in constant 2015 US$) in Belgium in 2002 and the Taxes (in constant 2015 US$) in Ethiopia in 2003?
Your response must be concise. 2.62e+1. What is the difference between the Taxes (in constant 2015 US$) in Belgium in 2002 and the Taxes (in constant 2015 US$) in Philippines in 2003?
Ensure brevity in your answer.  2.14e+1. What is the difference between the Taxes (in constant 2015 US$) in Cameroon in 2002 and the Taxes (in constant 2015 US$) in Ethiopia in 2003?
Your answer should be compact. 2.20e+08. What is the difference between the Taxes (in constant 2015 US$) in Cameroon in 2002 and the Taxes (in constant 2015 US$) in Philippines in 2003?
Offer a terse response. -4.52e+09. What is the difference between the Taxes (in constant 2015 US$) of Ethiopia in 2002 and the Taxes (in constant 2015 US$) of Philippines in 2003?
Offer a very short reply. -4.79e+09. What is the difference between the Taxes (in constant 2015 US$) of Belgium in 2002 and the Taxes (in constant 2015 US$) of Cameroon in 2004?
Keep it short and to the point. 2.57e+1. What is the difference between the Taxes (in constant 2015 US$) of Belgium in 2002 and the Taxes (in constant 2015 US$) of Ethiopia in 2004?
Offer a very short reply. 2.59e+1. What is the difference between the Taxes (in constant 2015 US$) of Belgium in 2002 and the Taxes (in constant 2015 US$) of Philippines in 2004?
Provide a succinct answer. 2.12e+1. What is the difference between the Taxes (in constant 2015 US$) in Cameroon in 2002 and the Taxes (in constant 2015 US$) in Ethiopia in 2004?
Keep it short and to the point. -3.78e+07. What is the difference between the Taxes (in constant 2015 US$) in Cameroon in 2002 and the Taxes (in constant 2015 US$) in Philippines in 2004?
Offer a terse response. -4.75e+09. What is the difference between the Taxes (in constant 2015 US$) of Ethiopia in 2002 and the Taxes (in constant 2015 US$) of Philippines in 2004?
Give a very brief answer. -5.02e+09. What is the difference between the Taxes (in constant 2015 US$) of Belgium in 2002 and the Taxes (in constant 2015 US$) of Cameroon in 2005?
Your answer should be compact. 2.55e+1. What is the difference between the Taxes (in constant 2015 US$) in Belgium in 2002 and the Taxes (in constant 2015 US$) in Ethiopia in 2005?
Provide a succinct answer. 2.58e+1. What is the difference between the Taxes (in constant 2015 US$) of Belgium in 2002 and the Taxes (in constant 2015 US$) of Philippines in 2005?
Your answer should be compact. 2.01e+1. What is the difference between the Taxes (in constant 2015 US$) in Cameroon in 2002 and the Taxes (in constant 2015 US$) in Ethiopia in 2005?
Your response must be concise. -1.49e+08. What is the difference between the Taxes (in constant 2015 US$) in Cameroon in 2002 and the Taxes (in constant 2015 US$) in Philippines in 2005?
Provide a short and direct response. -5.89e+09. What is the difference between the Taxes (in constant 2015 US$) of Ethiopia in 2002 and the Taxes (in constant 2015 US$) of Philippines in 2005?
Give a very brief answer. -6.16e+09. What is the difference between the Taxes (in constant 2015 US$) in Belgium in 2002 and the Taxes (in constant 2015 US$) in Cameroon in 2006?
Offer a terse response. 2.54e+1. What is the difference between the Taxes (in constant 2015 US$) of Belgium in 2002 and the Taxes (in constant 2015 US$) of Ethiopia in 2006?
Make the answer very short. 2.57e+1. What is the difference between the Taxes (in constant 2015 US$) in Belgium in 2002 and the Taxes (in constant 2015 US$) in Philippines in 2006?
Provide a short and direct response. 1.77e+1. What is the difference between the Taxes (in constant 2015 US$) of Cameroon in 2002 and the Taxes (in constant 2015 US$) of Ethiopia in 2006?
Your response must be concise. -2.88e+08. What is the difference between the Taxes (in constant 2015 US$) of Cameroon in 2002 and the Taxes (in constant 2015 US$) of Philippines in 2006?
Keep it short and to the point. -8.31e+09. What is the difference between the Taxes (in constant 2015 US$) of Ethiopia in 2002 and the Taxes (in constant 2015 US$) of Philippines in 2006?
Keep it short and to the point. -8.58e+09. What is the difference between the Taxes (in constant 2015 US$) of Belgium in 2003 and the Taxes (in constant 2015 US$) of Cameroon in 2004?
Your response must be concise. 3.14e+1. What is the difference between the Taxes (in constant 2015 US$) of Belgium in 2003 and the Taxes (in constant 2015 US$) of Ethiopia in 2004?
Provide a short and direct response. 3.17e+1. What is the difference between the Taxes (in constant 2015 US$) in Belgium in 2003 and the Taxes (in constant 2015 US$) in Philippines in 2004?
Your answer should be very brief. 2.70e+1. What is the difference between the Taxes (in constant 2015 US$) in Cameroon in 2003 and the Taxes (in constant 2015 US$) in Ethiopia in 2004?
Provide a succinct answer. 1.43e+08. What is the difference between the Taxes (in constant 2015 US$) of Cameroon in 2003 and the Taxes (in constant 2015 US$) of Philippines in 2004?
Your answer should be very brief. -4.57e+09. What is the difference between the Taxes (in constant 2015 US$) in Ethiopia in 2003 and the Taxes (in constant 2015 US$) in Philippines in 2004?
Provide a short and direct response. -4.97e+09. What is the difference between the Taxes (in constant 2015 US$) in Belgium in 2003 and the Taxes (in constant 2015 US$) in Cameroon in 2005?
Provide a succinct answer. 3.13e+1. What is the difference between the Taxes (in constant 2015 US$) in Belgium in 2003 and the Taxes (in constant 2015 US$) in Ethiopia in 2005?
Keep it short and to the point. 3.16e+1. What is the difference between the Taxes (in constant 2015 US$) of Belgium in 2003 and the Taxes (in constant 2015 US$) of Philippines in 2005?
Give a very brief answer. 2.58e+1. What is the difference between the Taxes (in constant 2015 US$) in Cameroon in 2003 and the Taxes (in constant 2015 US$) in Ethiopia in 2005?
Provide a succinct answer. 3.21e+07. What is the difference between the Taxes (in constant 2015 US$) in Cameroon in 2003 and the Taxes (in constant 2015 US$) in Philippines in 2005?
Provide a short and direct response. -5.71e+09. What is the difference between the Taxes (in constant 2015 US$) in Ethiopia in 2003 and the Taxes (in constant 2015 US$) in Philippines in 2005?
Offer a very short reply. -6.11e+09. What is the difference between the Taxes (in constant 2015 US$) of Belgium in 2003 and the Taxes (in constant 2015 US$) of Cameroon in 2006?
Keep it short and to the point. 3.11e+1. What is the difference between the Taxes (in constant 2015 US$) in Belgium in 2003 and the Taxes (in constant 2015 US$) in Ethiopia in 2006?
Your response must be concise. 3.14e+1. What is the difference between the Taxes (in constant 2015 US$) of Belgium in 2003 and the Taxes (in constant 2015 US$) of Philippines in 2006?
Your answer should be very brief. 2.34e+1. What is the difference between the Taxes (in constant 2015 US$) in Cameroon in 2003 and the Taxes (in constant 2015 US$) in Ethiopia in 2006?
Provide a short and direct response. -1.06e+08. What is the difference between the Taxes (in constant 2015 US$) of Cameroon in 2003 and the Taxes (in constant 2015 US$) of Philippines in 2006?
Give a very brief answer. -8.13e+09. What is the difference between the Taxes (in constant 2015 US$) in Ethiopia in 2003 and the Taxes (in constant 2015 US$) in Philippines in 2006?
Your answer should be compact. -8.53e+09. What is the difference between the Taxes (in constant 2015 US$) of Belgium in 2004 and the Taxes (in constant 2015 US$) of Cameroon in 2005?
Keep it short and to the point. 3.81e+1. What is the difference between the Taxes (in constant 2015 US$) of Belgium in 2004 and the Taxes (in constant 2015 US$) of Ethiopia in 2005?
Make the answer very short. 3.83e+1. What is the difference between the Taxes (in constant 2015 US$) in Belgium in 2004 and the Taxes (in constant 2015 US$) in Philippines in 2005?
Make the answer very short. 3.26e+1. What is the difference between the Taxes (in constant 2015 US$) of Cameroon in 2004 and the Taxes (in constant 2015 US$) of Ethiopia in 2005?
Provide a short and direct response. 1.43e+08. What is the difference between the Taxes (in constant 2015 US$) of Cameroon in 2004 and the Taxes (in constant 2015 US$) of Philippines in 2005?
Give a very brief answer. -5.60e+09. What is the difference between the Taxes (in constant 2015 US$) of Ethiopia in 2004 and the Taxes (in constant 2015 US$) of Philippines in 2005?
Ensure brevity in your answer.  -5.85e+09. What is the difference between the Taxes (in constant 2015 US$) of Belgium in 2004 and the Taxes (in constant 2015 US$) of Cameroon in 2006?
Your response must be concise. 3.79e+1. What is the difference between the Taxes (in constant 2015 US$) of Belgium in 2004 and the Taxes (in constant 2015 US$) of Ethiopia in 2006?
Provide a short and direct response. 3.82e+1. What is the difference between the Taxes (in constant 2015 US$) in Belgium in 2004 and the Taxes (in constant 2015 US$) in Philippines in 2006?
Offer a very short reply. 3.02e+1. What is the difference between the Taxes (in constant 2015 US$) of Cameroon in 2004 and the Taxes (in constant 2015 US$) of Ethiopia in 2006?
Provide a short and direct response. 4.90e+06. What is the difference between the Taxes (in constant 2015 US$) in Cameroon in 2004 and the Taxes (in constant 2015 US$) in Philippines in 2006?
Offer a terse response. -8.02e+09. What is the difference between the Taxes (in constant 2015 US$) in Ethiopia in 2004 and the Taxes (in constant 2015 US$) in Philippines in 2006?
Ensure brevity in your answer.  -8.27e+09. What is the difference between the Taxes (in constant 2015 US$) of Belgium in 2005 and the Taxes (in constant 2015 US$) of Cameroon in 2006?
Ensure brevity in your answer.  3.96e+1. What is the difference between the Taxes (in constant 2015 US$) in Belgium in 2005 and the Taxes (in constant 2015 US$) in Ethiopia in 2006?
Provide a succinct answer. 3.99e+1. What is the difference between the Taxes (in constant 2015 US$) in Belgium in 2005 and the Taxes (in constant 2015 US$) in Philippines in 2006?
Ensure brevity in your answer.  3.19e+1. What is the difference between the Taxes (in constant 2015 US$) in Cameroon in 2005 and the Taxes (in constant 2015 US$) in Ethiopia in 2006?
Offer a terse response. 1.38e+08. What is the difference between the Taxes (in constant 2015 US$) of Cameroon in 2005 and the Taxes (in constant 2015 US$) of Philippines in 2006?
Provide a short and direct response. -7.89e+09. What is the difference between the Taxes (in constant 2015 US$) of Ethiopia in 2005 and the Taxes (in constant 2015 US$) of Philippines in 2006?
Keep it short and to the point. -8.16e+09. What is the average Taxes (in constant 2015 US$) of Belgium per year?
Provide a succinct answer. 3.26e+1. What is the average Taxes (in constant 2015 US$) of Cameroon per year?
Offer a very short reply. 9.83e+08. What is the average Taxes (in constant 2015 US$) in Ethiopia per year?
Provide a succinct answer. 7.20e+08. What is the average Taxes (in constant 2015 US$) in Philippines per year?
Make the answer very short. 6.12e+09. In the year 1999, what is the difference between the Taxes (in constant 2015 US$) in Belgium and Taxes (in constant 2015 US$) in Cameroon?
Your response must be concise. 2.70e+1. In the year 1999, what is the difference between the Taxes (in constant 2015 US$) of Belgium and Taxes (in constant 2015 US$) of Ethiopia?
Ensure brevity in your answer.  2.73e+1. In the year 1999, what is the difference between the Taxes (in constant 2015 US$) of Belgium and Taxes (in constant 2015 US$) of Philippines?
Keep it short and to the point. 2.16e+1. In the year 1999, what is the difference between the Taxes (in constant 2015 US$) in Cameroon and Taxes (in constant 2015 US$) in Ethiopia?
Your response must be concise. 2.73e+08. In the year 1999, what is the difference between the Taxes (in constant 2015 US$) in Cameroon and Taxes (in constant 2015 US$) in Philippines?
Your answer should be very brief. -5.39e+09. In the year 1999, what is the difference between the Taxes (in constant 2015 US$) in Ethiopia and Taxes (in constant 2015 US$) in Philippines?
Make the answer very short. -5.67e+09. In the year 2000, what is the difference between the Taxes (in constant 2015 US$) of Belgium and Taxes (in constant 2015 US$) of Cameroon?
Offer a terse response. 2.49e+1. In the year 2000, what is the difference between the Taxes (in constant 2015 US$) of Belgium and Taxes (in constant 2015 US$) of Ethiopia?
Offer a very short reply. 2.50e+1. In the year 2000, what is the difference between the Taxes (in constant 2015 US$) of Belgium and Taxes (in constant 2015 US$) of Philippines?
Offer a terse response. 1.99e+1. In the year 2000, what is the difference between the Taxes (in constant 2015 US$) of Cameroon and Taxes (in constant 2015 US$) of Ethiopia?
Offer a very short reply. 1.66e+08. In the year 2000, what is the difference between the Taxes (in constant 2015 US$) of Cameroon and Taxes (in constant 2015 US$) of Philippines?
Provide a short and direct response. -4.92e+09. In the year 2000, what is the difference between the Taxes (in constant 2015 US$) of Ethiopia and Taxes (in constant 2015 US$) of Philippines?
Give a very brief answer. -5.09e+09. In the year 2001, what is the difference between the Taxes (in constant 2015 US$) of Belgium and Taxes (in constant 2015 US$) of Cameroon?
Give a very brief answer. 2.36e+1. In the year 2001, what is the difference between the Taxes (in constant 2015 US$) of Belgium and Taxes (in constant 2015 US$) of Ethiopia?
Give a very brief answer. 2.37e+1. In the year 2001, what is the difference between the Taxes (in constant 2015 US$) of Belgium and Taxes (in constant 2015 US$) of Philippines?
Provide a succinct answer. 1.92e+1. In the year 2001, what is the difference between the Taxes (in constant 2015 US$) of Cameroon and Taxes (in constant 2015 US$) of Ethiopia?
Provide a short and direct response. 1.54e+08. In the year 2001, what is the difference between the Taxes (in constant 2015 US$) of Cameroon and Taxes (in constant 2015 US$) of Philippines?
Your answer should be very brief. -4.37e+09. In the year 2001, what is the difference between the Taxes (in constant 2015 US$) of Ethiopia and Taxes (in constant 2015 US$) of Philippines?
Make the answer very short. -4.52e+09. In the year 2002, what is the difference between the Taxes (in constant 2015 US$) in Belgium and Taxes (in constant 2015 US$) in Cameroon?
Make the answer very short. 2.60e+1. In the year 2002, what is the difference between the Taxes (in constant 2015 US$) in Belgium and Taxes (in constant 2015 US$) in Ethiopia?
Ensure brevity in your answer.  2.62e+1. In the year 2002, what is the difference between the Taxes (in constant 2015 US$) of Belgium and Taxes (in constant 2015 US$) of Philippines?
Ensure brevity in your answer.  2.15e+1. In the year 2002, what is the difference between the Taxes (in constant 2015 US$) of Cameroon and Taxes (in constant 2015 US$) of Ethiopia?
Provide a succinct answer. 2.70e+08. In the year 2002, what is the difference between the Taxes (in constant 2015 US$) in Cameroon and Taxes (in constant 2015 US$) in Philippines?
Provide a succinct answer. -4.47e+09. In the year 2002, what is the difference between the Taxes (in constant 2015 US$) of Ethiopia and Taxes (in constant 2015 US$) of Philippines?
Give a very brief answer. -4.74e+09. In the year 2003, what is the difference between the Taxes (in constant 2015 US$) in Belgium and Taxes (in constant 2015 US$) in Cameroon?
Your answer should be very brief. 3.15e+1. In the year 2003, what is the difference between the Taxes (in constant 2015 US$) in Belgium and Taxes (in constant 2015 US$) in Ethiopia?
Make the answer very short. 3.19e+1. In the year 2003, what is the difference between the Taxes (in constant 2015 US$) of Belgium and Taxes (in constant 2015 US$) of Philippines?
Give a very brief answer. 2.72e+1. In the year 2003, what is the difference between the Taxes (in constant 2015 US$) of Cameroon and Taxes (in constant 2015 US$) of Ethiopia?
Your answer should be very brief. 4.01e+08. In the year 2003, what is the difference between the Taxes (in constant 2015 US$) in Cameroon and Taxes (in constant 2015 US$) in Philippines?
Your answer should be compact. -4.34e+09. In the year 2003, what is the difference between the Taxes (in constant 2015 US$) of Ethiopia and Taxes (in constant 2015 US$) of Philippines?
Provide a short and direct response. -4.74e+09. In the year 2004, what is the difference between the Taxes (in constant 2015 US$) of Belgium and Taxes (in constant 2015 US$) of Cameroon?
Offer a terse response. 3.82e+1. In the year 2004, what is the difference between the Taxes (in constant 2015 US$) of Belgium and Taxes (in constant 2015 US$) of Ethiopia?
Provide a short and direct response. 3.85e+1. In the year 2004, what is the difference between the Taxes (in constant 2015 US$) of Belgium and Taxes (in constant 2015 US$) of Philippines?
Your answer should be compact. 3.37e+1. In the year 2004, what is the difference between the Taxes (in constant 2015 US$) of Cameroon and Taxes (in constant 2015 US$) of Ethiopia?
Provide a succinct answer. 2.55e+08. In the year 2004, what is the difference between the Taxes (in constant 2015 US$) of Cameroon and Taxes (in constant 2015 US$) of Philippines?
Your answer should be compact. -4.45e+09. In the year 2004, what is the difference between the Taxes (in constant 2015 US$) in Ethiopia and Taxes (in constant 2015 US$) in Philippines?
Make the answer very short. -4.71e+09. In the year 2005, what is the difference between the Taxes (in constant 2015 US$) of Belgium and Taxes (in constant 2015 US$) of Cameroon?
Your answer should be very brief. 3.98e+1. In the year 2005, what is the difference between the Taxes (in constant 2015 US$) of Belgium and Taxes (in constant 2015 US$) of Ethiopia?
Your answer should be very brief. 4.00e+1. In the year 2005, what is the difference between the Taxes (in constant 2015 US$) of Belgium and Taxes (in constant 2015 US$) of Philippines?
Provide a succinct answer. 3.43e+1. In the year 2005, what is the difference between the Taxes (in constant 2015 US$) in Cameroon and Taxes (in constant 2015 US$) in Ethiopia?
Ensure brevity in your answer.  2.76e+08. In the year 2005, what is the difference between the Taxes (in constant 2015 US$) in Cameroon and Taxes (in constant 2015 US$) in Philippines?
Make the answer very short. -5.46e+09. In the year 2005, what is the difference between the Taxes (in constant 2015 US$) in Ethiopia and Taxes (in constant 2015 US$) in Philippines?
Ensure brevity in your answer.  -5.74e+09. In the year 2006, what is the difference between the Taxes (in constant 2015 US$) of Belgium and Taxes (in constant 2015 US$) of Cameroon?
Your response must be concise. 4.23e+1. In the year 2006, what is the difference between the Taxes (in constant 2015 US$) in Belgium and Taxes (in constant 2015 US$) in Ethiopia?
Offer a terse response. 4.26e+1. In the year 2006, what is the difference between the Taxes (in constant 2015 US$) in Belgium and Taxes (in constant 2015 US$) in Philippines?
Provide a short and direct response. 3.46e+1. In the year 2006, what is the difference between the Taxes (in constant 2015 US$) of Cameroon and Taxes (in constant 2015 US$) of Ethiopia?
Keep it short and to the point. 3.09e+08. In the year 2006, what is the difference between the Taxes (in constant 2015 US$) in Cameroon and Taxes (in constant 2015 US$) in Philippines?
Make the answer very short. -7.71e+09. In the year 2006, what is the difference between the Taxes (in constant 2015 US$) in Ethiopia and Taxes (in constant 2015 US$) in Philippines?
Ensure brevity in your answer.  -8.02e+09. What is the ratio of the Taxes (in constant 2015 US$) of Belgium in 1999 to that in 2000?
Give a very brief answer. 1.09. What is the ratio of the Taxes (in constant 2015 US$) in Cameroon in 1999 to that in 2000?
Make the answer very short. 1.1. What is the ratio of the Taxes (in constant 2015 US$) of Ethiopia in 1999 to that in 2000?
Your answer should be compact. 0.93. What is the ratio of the Taxes (in constant 2015 US$) of Philippines in 1999 to that in 2000?
Provide a succinct answer. 1.1. What is the ratio of the Taxes (in constant 2015 US$) in Belgium in 1999 to that in 2001?
Offer a very short reply. 1.14. What is the ratio of the Taxes (in constant 2015 US$) of Cameroon in 1999 to that in 2001?
Offer a very short reply. 1.03. What is the ratio of the Taxes (in constant 2015 US$) of Ethiopia in 1999 to that in 2001?
Keep it short and to the point. 0.84. What is the ratio of the Taxes (in constant 2015 US$) in Philippines in 1999 to that in 2001?
Your response must be concise. 1.2. What is the ratio of the Taxes (in constant 2015 US$) in Cameroon in 1999 to that in 2002?
Provide a succinct answer. 0.93. What is the ratio of the Taxes (in constant 2015 US$) in Ethiopia in 1999 to that in 2002?
Keep it short and to the point. 0.89. What is the ratio of the Taxes (in constant 2015 US$) of Philippines in 1999 to that in 2002?
Provide a short and direct response. 1.16. What is the ratio of the Taxes (in constant 2015 US$) in Belgium in 1999 to that in 2003?
Give a very brief answer. 0.85. What is the ratio of the Taxes (in constant 2015 US$) in Cameroon in 1999 to that in 2003?
Make the answer very short. 0.76. What is the ratio of the Taxes (in constant 2015 US$) of Ethiopia in 1999 to that in 2003?
Provide a short and direct response. 0.82. What is the ratio of the Taxes (in constant 2015 US$) of Philippines in 1999 to that in 2003?
Your response must be concise. 1.15. What is the ratio of the Taxes (in constant 2015 US$) in Belgium in 1999 to that in 2004?
Your response must be concise. 0.71. What is the ratio of the Taxes (in constant 2015 US$) of Cameroon in 1999 to that in 2004?
Your answer should be very brief. 0.69. What is the ratio of the Taxes (in constant 2015 US$) of Ethiopia in 1999 to that in 2004?
Offer a terse response. 0.57. What is the ratio of the Taxes (in constant 2015 US$) in Philippines in 1999 to that in 2004?
Your response must be concise. 1.11. What is the ratio of the Taxes (in constant 2015 US$) in Belgium in 1999 to that in 2005?
Your answer should be compact. 0.68. What is the ratio of the Taxes (in constant 2015 US$) in Cameroon in 1999 to that in 2005?
Give a very brief answer. 0.61. What is the ratio of the Taxes (in constant 2015 US$) of Ethiopia in 1999 to that in 2005?
Provide a short and direct response. 0.51. What is the ratio of the Taxes (in constant 2015 US$) in Philippines in 1999 to that in 2005?
Your answer should be very brief. 0.92. What is the ratio of the Taxes (in constant 2015 US$) in Belgium in 1999 to that in 2006?
Provide a short and direct response. 0.64. What is the ratio of the Taxes (in constant 2015 US$) of Cameroon in 1999 to that in 2006?
Ensure brevity in your answer.  0.54. What is the ratio of the Taxes (in constant 2015 US$) in Ethiopia in 1999 to that in 2006?
Provide a short and direct response. 0.45. What is the ratio of the Taxes (in constant 2015 US$) in Philippines in 1999 to that in 2006?
Offer a very short reply. 0.67. What is the ratio of the Taxes (in constant 2015 US$) of Belgium in 2000 to that in 2001?
Give a very brief answer. 1.05. What is the ratio of the Taxes (in constant 2015 US$) in Cameroon in 2000 to that in 2001?
Provide a succinct answer. 0.93. What is the ratio of the Taxes (in constant 2015 US$) in Ethiopia in 2000 to that in 2001?
Offer a terse response. 0.9. What is the ratio of the Taxes (in constant 2015 US$) of Philippines in 2000 to that in 2001?
Ensure brevity in your answer.  1.1. What is the ratio of the Taxes (in constant 2015 US$) of Belgium in 2000 to that in 2002?
Your answer should be compact. 0.95. What is the ratio of the Taxes (in constant 2015 US$) of Cameroon in 2000 to that in 2002?
Give a very brief answer. 0.84. What is the ratio of the Taxes (in constant 2015 US$) in Ethiopia in 2000 to that in 2002?
Ensure brevity in your answer.  0.95. What is the ratio of the Taxes (in constant 2015 US$) in Philippines in 2000 to that in 2002?
Provide a short and direct response. 1.06. What is the ratio of the Taxes (in constant 2015 US$) of Belgium in 2000 to that in 2003?
Provide a short and direct response. 0.79. What is the ratio of the Taxes (in constant 2015 US$) in Cameroon in 2000 to that in 2003?
Offer a terse response. 0.69. What is the ratio of the Taxes (in constant 2015 US$) in Ethiopia in 2000 to that in 2003?
Offer a very short reply. 0.88. What is the ratio of the Taxes (in constant 2015 US$) of Philippines in 2000 to that in 2003?
Your response must be concise. 1.05. What is the ratio of the Taxes (in constant 2015 US$) of Belgium in 2000 to that in 2004?
Your response must be concise. 0.65. What is the ratio of the Taxes (in constant 2015 US$) of Cameroon in 2000 to that in 2004?
Offer a very short reply. 0.62. What is the ratio of the Taxes (in constant 2015 US$) of Ethiopia in 2000 to that in 2004?
Your response must be concise. 0.62. What is the ratio of the Taxes (in constant 2015 US$) of Philippines in 2000 to that in 2004?
Offer a terse response. 1.01. What is the ratio of the Taxes (in constant 2015 US$) in Belgium in 2000 to that in 2005?
Offer a terse response. 0.62. What is the ratio of the Taxes (in constant 2015 US$) in Cameroon in 2000 to that in 2005?
Provide a succinct answer. 0.56. What is the ratio of the Taxes (in constant 2015 US$) in Ethiopia in 2000 to that in 2005?
Provide a succinct answer. 0.55. What is the ratio of the Taxes (in constant 2015 US$) in Philippines in 2000 to that in 2005?
Make the answer very short. 0.84. What is the ratio of the Taxes (in constant 2015 US$) in Belgium in 2000 to that in 2006?
Offer a terse response. 0.58. What is the ratio of the Taxes (in constant 2015 US$) of Cameroon in 2000 to that in 2006?
Provide a short and direct response. 0.49. What is the ratio of the Taxes (in constant 2015 US$) in Ethiopia in 2000 to that in 2006?
Offer a very short reply. 0.48. What is the ratio of the Taxes (in constant 2015 US$) in Philippines in 2000 to that in 2006?
Your answer should be compact. 0.61. What is the ratio of the Taxes (in constant 2015 US$) of Belgium in 2001 to that in 2002?
Keep it short and to the point. 0.91. What is the ratio of the Taxes (in constant 2015 US$) of Cameroon in 2001 to that in 2002?
Your answer should be compact. 0.9. What is the ratio of the Taxes (in constant 2015 US$) of Ethiopia in 2001 to that in 2002?
Your answer should be very brief. 1.06. What is the ratio of the Taxes (in constant 2015 US$) in Philippines in 2001 to that in 2002?
Offer a very short reply. 0.96. What is the ratio of the Taxes (in constant 2015 US$) of Belgium in 2001 to that in 2003?
Make the answer very short. 0.75. What is the ratio of the Taxes (in constant 2015 US$) of Cameroon in 2001 to that in 2003?
Ensure brevity in your answer.  0.74. What is the ratio of the Taxes (in constant 2015 US$) of Ethiopia in 2001 to that in 2003?
Your response must be concise. 0.98. What is the ratio of the Taxes (in constant 2015 US$) in Philippines in 2001 to that in 2003?
Ensure brevity in your answer.  0.96. What is the ratio of the Taxes (in constant 2015 US$) of Belgium in 2001 to that in 2004?
Ensure brevity in your answer.  0.62. What is the ratio of the Taxes (in constant 2015 US$) in Cameroon in 2001 to that in 2004?
Provide a succinct answer. 0.67. What is the ratio of the Taxes (in constant 2015 US$) of Ethiopia in 2001 to that in 2004?
Your answer should be very brief. 0.69. What is the ratio of the Taxes (in constant 2015 US$) of Philippines in 2001 to that in 2004?
Your response must be concise. 0.92. What is the ratio of the Taxes (in constant 2015 US$) of Belgium in 2001 to that in 2005?
Ensure brevity in your answer.  0.59. What is the ratio of the Taxes (in constant 2015 US$) in Cameroon in 2001 to that in 2005?
Provide a succinct answer. 0.6. What is the ratio of the Taxes (in constant 2015 US$) in Ethiopia in 2001 to that in 2005?
Provide a succinct answer. 0.61. What is the ratio of the Taxes (in constant 2015 US$) in Philippines in 2001 to that in 2005?
Provide a succinct answer. 0.76. What is the ratio of the Taxes (in constant 2015 US$) of Belgium in 2001 to that in 2006?
Your response must be concise. 0.56. What is the ratio of the Taxes (in constant 2015 US$) in Cameroon in 2001 to that in 2006?
Ensure brevity in your answer.  0.53. What is the ratio of the Taxes (in constant 2015 US$) of Ethiopia in 2001 to that in 2006?
Provide a short and direct response. 0.53. What is the ratio of the Taxes (in constant 2015 US$) in Philippines in 2001 to that in 2006?
Provide a succinct answer. 0.56. What is the ratio of the Taxes (in constant 2015 US$) in Belgium in 2002 to that in 2003?
Ensure brevity in your answer.  0.82. What is the ratio of the Taxes (in constant 2015 US$) of Cameroon in 2002 to that in 2003?
Make the answer very short. 0.82. What is the ratio of the Taxes (in constant 2015 US$) of Ethiopia in 2002 to that in 2003?
Offer a terse response. 0.92. What is the ratio of the Taxes (in constant 2015 US$) in Philippines in 2002 to that in 2003?
Provide a short and direct response. 0.99. What is the ratio of the Taxes (in constant 2015 US$) of Belgium in 2002 to that in 2004?
Your response must be concise. 0.68. What is the ratio of the Taxes (in constant 2015 US$) of Cameroon in 2002 to that in 2004?
Ensure brevity in your answer.  0.74. What is the ratio of the Taxes (in constant 2015 US$) in Ethiopia in 2002 to that in 2004?
Give a very brief answer. 0.64. What is the ratio of the Taxes (in constant 2015 US$) of Philippines in 2002 to that in 2004?
Ensure brevity in your answer.  0.95. What is the ratio of the Taxes (in constant 2015 US$) in Belgium in 2002 to that in 2005?
Ensure brevity in your answer.  0.65. What is the ratio of the Taxes (in constant 2015 US$) in Cameroon in 2002 to that in 2005?
Offer a very short reply. 0.66. What is the ratio of the Taxes (in constant 2015 US$) in Ethiopia in 2002 to that in 2005?
Your response must be concise. 0.57. What is the ratio of the Taxes (in constant 2015 US$) in Philippines in 2002 to that in 2005?
Your answer should be compact. 0.79. What is the ratio of the Taxes (in constant 2015 US$) of Belgium in 2002 to that in 2006?
Your response must be concise. 0.61. What is the ratio of the Taxes (in constant 2015 US$) of Cameroon in 2002 to that in 2006?
Give a very brief answer. 0.58. What is the ratio of the Taxes (in constant 2015 US$) in Ethiopia in 2002 to that in 2006?
Offer a very short reply. 0.5. What is the ratio of the Taxes (in constant 2015 US$) in Philippines in 2002 to that in 2006?
Keep it short and to the point. 0.58. What is the ratio of the Taxes (in constant 2015 US$) of Belgium in 2003 to that in 2004?
Keep it short and to the point. 0.83. What is the ratio of the Taxes (in constant 2015 US$) in Cameroon in 2003 to that in 2004?
Ensure brevity in your answer.  0.9. What is the ratio of the Taxes (in constant 2015 US$) of Ethiopia in 2003 to that in 2004?
Provide a short and direct response. 0.7. What is the ratio of the Taxes (in constant 2015 US$) of Philippines in 2003 to that in 2004?
Your answer should be compact. 0.96. What is the ratio of the Taxes (in constant 2015 US$) in Belgium in 2003 to that in 2005?
Your response must be concise. 0.79. What is the ratio of the Taxes (in constant 2015 US$) in Cameroon in 2003 to that in 2005?
Offer a very short reply. 0.81. What is the ratio of the Taxes (in constant 2015 US$) in Ethiopia in 2003 to that in 2005?
Provide a short and direct response. 0.62. What is the ratio of the Taxes (in constant 2015 US$) of Philippines in 2003 to that in 2005?
Provide a succinct answer. 0.8. What is the ratio of the Taxes (in constant 2015 US$) of Belgium in 2003 to that in 2006?
Offer a very short reply. 0.74. What is the ratio of the Taxes (in constant 2015 US$) in Cameroon in 2003 to that in 2006?
Keep it short and to the point. 0.71. What is the ratio of the Taxes (in constant 2015 US$) in Ethiopia in 2003 to that in 2006?
Your response must be concise. 0.55. What is the ratio of the Taxes (in constant 2015 US$) of Philippines in 2003 to that in 2006?
Give a very brief answer. 0.59. What is the ratio of the Taxes (in constant 2015 US$) in Belgium in 2004 to that in 2005?
Make the answer very short. 0.96. What is the ratio of the Taxes (in constant 2015 US$) in Cameroon in 2004 to that in 2005?
Provide a short and direct response. 0.89. What is the ratio of the Taxes (in constant 2015 US$) in Ethiopia in 2004 to that in 2005?
Keep it short and to the point. 0.89. What is the ratio of the Taxes (in constant 2015 US$) in Philippines in 2004 to that in 2005?
Your answer should be very brief. 0.83. What is the ratio of the Taxes (in constant 2015 US$) in Belgium in 2004 to that in 2006?
Provide a short and direct response. 0.9. What is the ratio of the Taxes (in constant 2015 US$) in Cameroon in 2004 to that in 2006?
Provide a succinct answer. 0.79. What is the ratio of the Taxes (in constant 2015 US$) in Ethiopia in 2004 to that in 2006?
Your answer should be very brief. 0.78. What is the ratio of the Taxes (in constant 2015 US$) in Philippines in 2004 to that in 2006?
Offer a very short reply. 0.61. What is the ratio of the Taxes (in constant 2015 US$) in Belgium in 2005 to that in 2006?
Keep it short and to the point. 0.94. What is the ratio of the Taxes (in constant 2015 US$) of Cameroon in 2005 to that in 2006?
Offer a terse response. 0.88. What is the ratio of the Taxes (in constant 2015 US$) of Ethiopia in 2005 to that in 2006?
Your answer should be very brief. 0.88. What is the ratio of the Taxes (in constant 2015 US$) in Philippines in 2005 to that in 2006?
Provide a short and direct response. 0.73. What is the difference between the highest and the second highest Taxes (in constant 2015 US$) of Belgium?
Make the answer very short. 2.68e+09. What is the difference between the highest and the second highest Taxes (in constant 2015 US$) in Cameroon?
Your answer should be very brief. 1.71e+08. What is the difference between the highest and the second highest Taxes (in constant 2015 US$) of Ethiopia?
Your answer should be very brief. 1.39e+08. What is the difference between the highest and the second highest Taxes (in constant 2015 US$) of Philippines?
Your answer should be very brief. 2.42e+09. What is the difference between the highest and the lowest Taxes (in constant 2015 US$) of Belgium?
Ensure brevity in your answer.  1.94e+1. What is the difference between the highest and the lowest Taxes (in constant 2015 US$) of Cameroon?
Provide a short and direct response. 7.27e+08. What is the difference between the highest and the lowest Taxes (in constant 2015 US$) in Ethiopia?
Make the answer very short. 6.20e+08. What is the difference between the highest and the lowest Taxes (in constant 2015 US$) in Philippines?
Offer a terse response. 4.03e+09. 